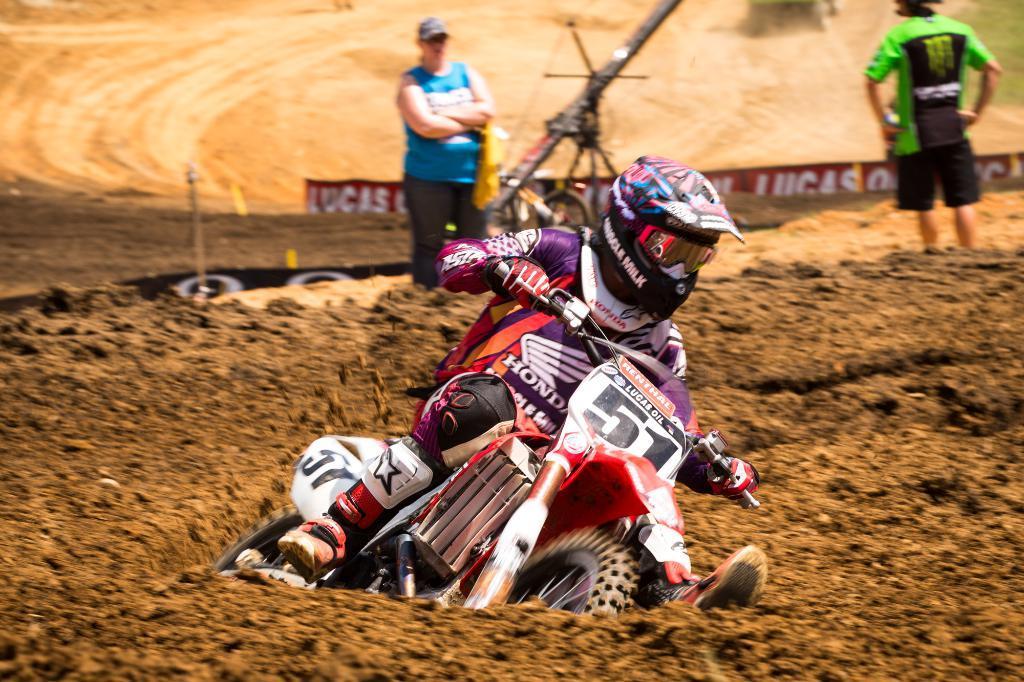Describe this image in one or two sentences. There is a man on the bike. He wear a helmet. Here we can see two persons are standing. And this is hoarding. 